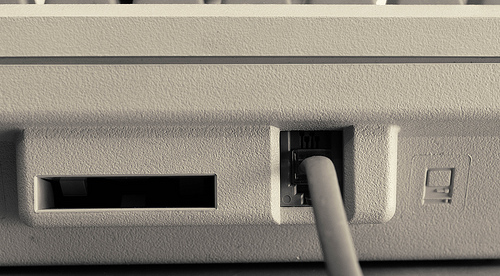<image>
Can you confirm if the cord is behind the plug? No. The cord is not behind the plug. From this viewpoint, the cord appears to be positioned elsewhere in the scene. 